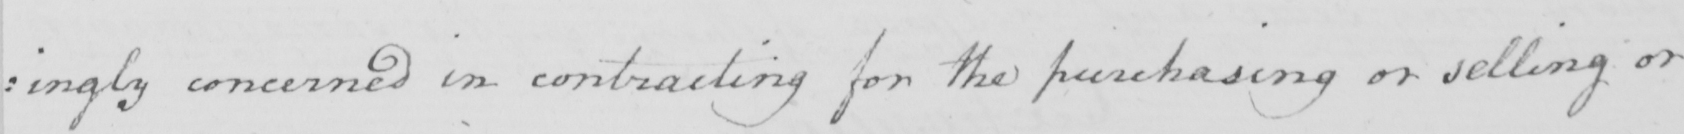Can you tell me what this handwritten text says? : ingly concerned in contracting for the purchasing or selling or 